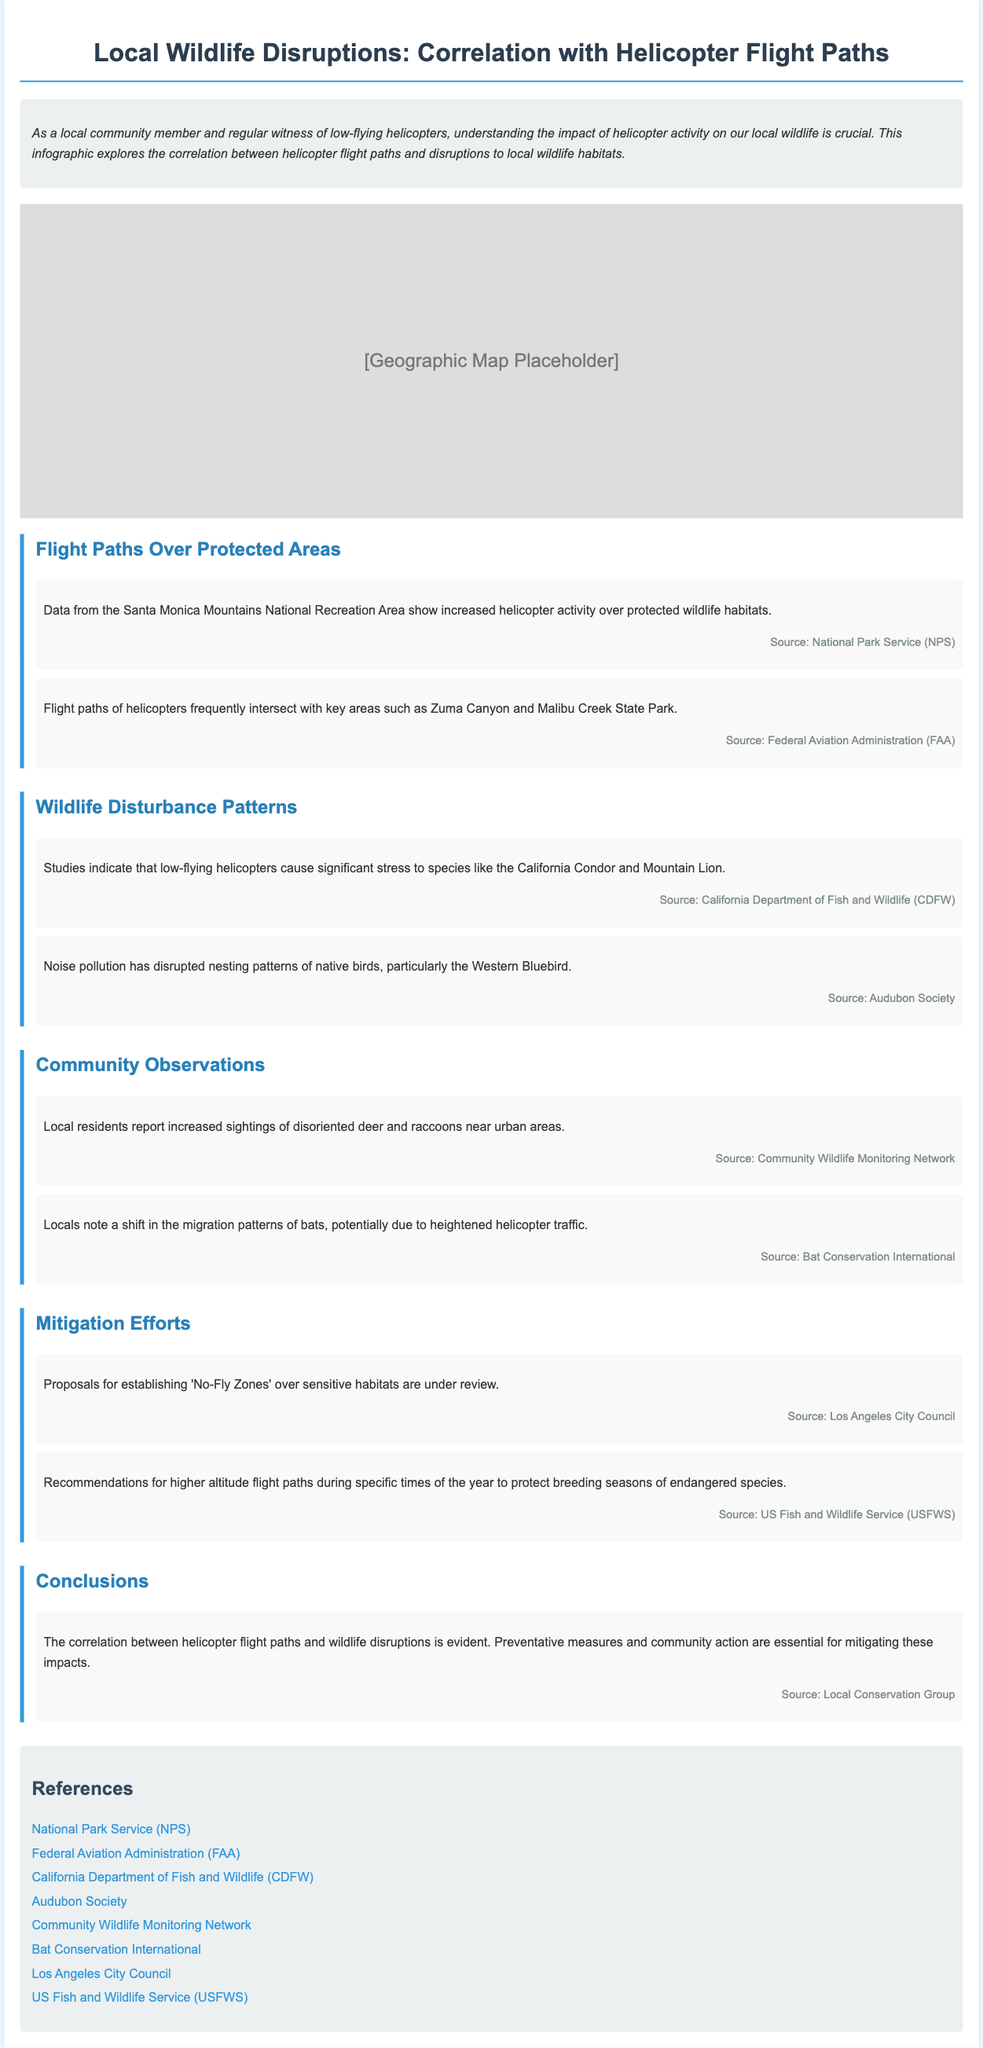what is the main topic of this infographic? The main topic of the infographic is the correlation between helicopter flight paths and disruptions to local wildlife habitats.
Answer: correlation between helicopter flight paths and wildlife disruptions how many protected areas are specifically mentioned? The infographic mentions two protected areas: Zuma Canyon and Malibu Creek State Park.
Answer: two which species experience significant stress from low-flying helicopters? The species that experience stress include the California Condor and Mountain Lion.
Answer: California Condor and Mountain Lion what is a reported effect of noise pollution on birds? Noise pollution has disrupted the nesting patterns of native birds, particularly the Western Bluebird.
Answer: disrupted nesting patterns what type of wildlife changes have residents observed? Local residents have reported increased sightings of disoriented deer and raccoons.
Answer: disoriented deer and raccoons which council is reviewing proposals for 'No-Fly Zones'? The Los Angeles City Council is reviewing proposals for 'No-Fly Zones'.
Answer: Los Angeles City Council what does the infographic suggest for the migration patterns of bats? The infographic notes a potential shift in the migration patterns of bats due to heightened helicopter traffic.
Answer: potential shift what kind of precautions are being recommended to protect endangered species? The recommended precaution is for higher altitude flight paths during specific times of the year to protect breeding seasons.
Answer: higher altitude flight paths what is emphasized as essential for mitigating wildlife disruptions? Preventative measures and community action are emphasized as essential.
Answer: Preventative measures and community action 